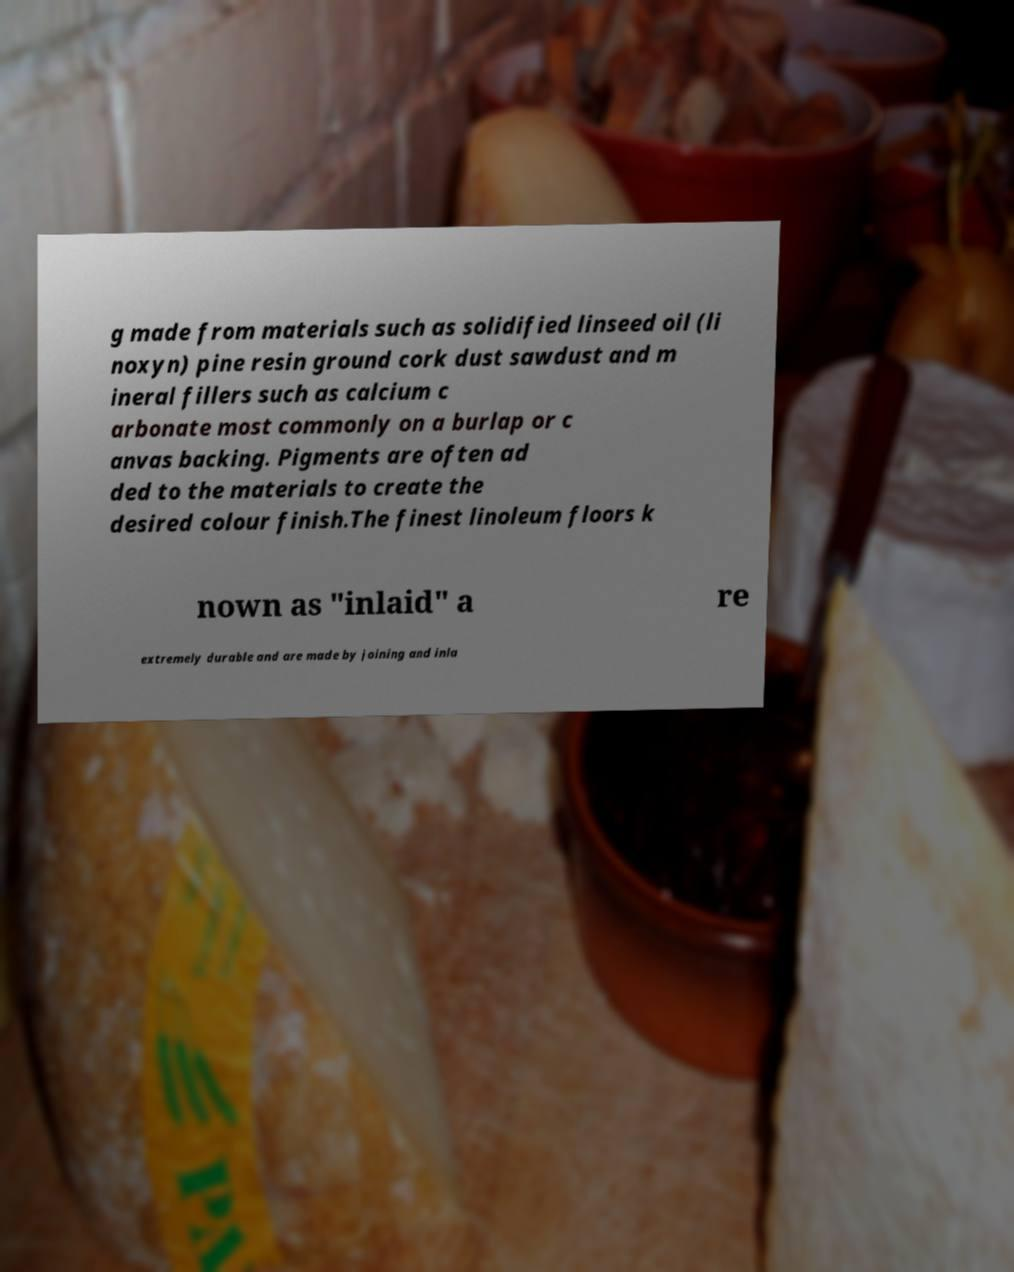There's text embedded in this image that I need extracted. Can you transcribe it verbatim? g made from materials such as solidified linseed oil (li noxyn) pine resin ground cork dust sawdust and m ineral fillers such as calcium c arbonate most commonly on a burlap or c anvas backing. Pigments are often ad ded to the materials to create the desired colour finish.The finest linoleum floors k nown as "inlaid" a re extremely durable and are made by joining and inla 